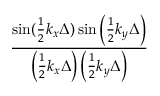<formula> <loc_0><loc_0><loc_500><loc_500>\frac { \sin ( \frac { 1 } { 2 } k _ { x } \Delta ) \sin \left ( \frac { 1 } { 2 } k _ { y } \Delta \right ) } { \left ( \frac { 1 } { 2 } k _ { x } \Delta \right ) \left ( \frac { 1 } { 2 } k _ { y } \Delta \right ) }</formula> 